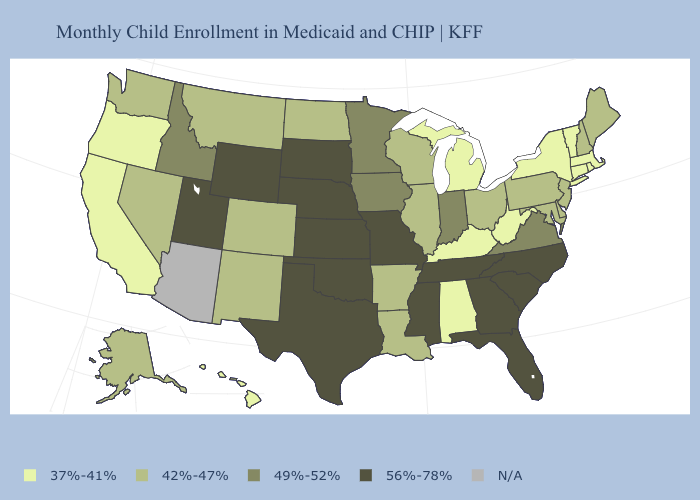Does South Carolina have the highest value in the USA?
Concise answer only. Yes. Name the states that have a value in the range 56%-78%?
Quick response, please. Florida, Georgia, Kansas, Mississippi, Missouri, Nebraska, North Carolina, Oklahoma, South Carolina, South Dakota, Tennessee, Texas, Utah, Wyoming. Name the states that have a value in the range 42%-47%?
Answer briefly. Alaska, Arkansas, Colorado, Delaware, Illinois, Louisiana, Maine, Maryland, Montana, Nevada, New Hampshire, New Jersey, New Mexico, North Dakota, Ohio, Pennsylvania, Washington, Wisconsin. Which states have the lowest value in the West?
Give a very brief answer. California, Hawaii, Oregon. What is the value of Alaska?
Be succinct. 42%-47%. Name the states that have a value in the range 37%-41%?
Answer briefly. Alabama, California, Connecticut, Hawaii, Kentucky, Massachusetts, Michigan, New York, Oregon, Rhode Island, Vermont, West Virginia. What is the lowest value in states that border Kentucky?
Answer briefly. 37%-41%. What is the value of Illinois?
Write a very short answer. 42%-47%. Among the states that border Colorado , which have the highest value?
Answer briefly. Kansas, Nebraska, Oklahoma, Utah, Wyoming. Name the states that have a value in the range N/A?
Give a very brief answer. Arizona. Name the states that have a value in the range 37%-41%?
Be succinct. Alabama, California, Connecticut, Hawaii, Kentucky, Massachusetts, Michigan, New York, Oregon, Rhode Island, Vermont, West Virginia. What is the value of New Hampshire?
Answer briefly. 42%-47%. What is the value of Hawaii?
Answer briefly. 37%-41%. 